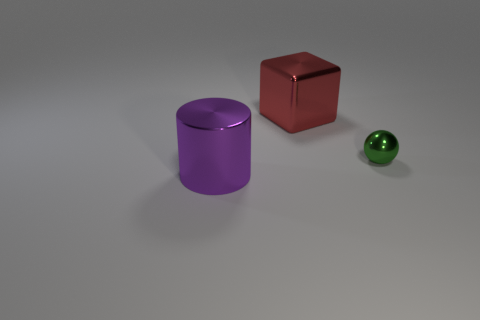Add 3 tiny green cylinders. How many objects exist? 6 Subtract all blocks. How many objects are left? 2 Subtract 1 green spheres. How many objects are left? 2 Subtract all red blocks. Subtract all big purple objects. How many objects are left? 1 Add 1 purple things. How many purple things are left? 2 Add 2 green matte things. How many green matte things exist? 2 